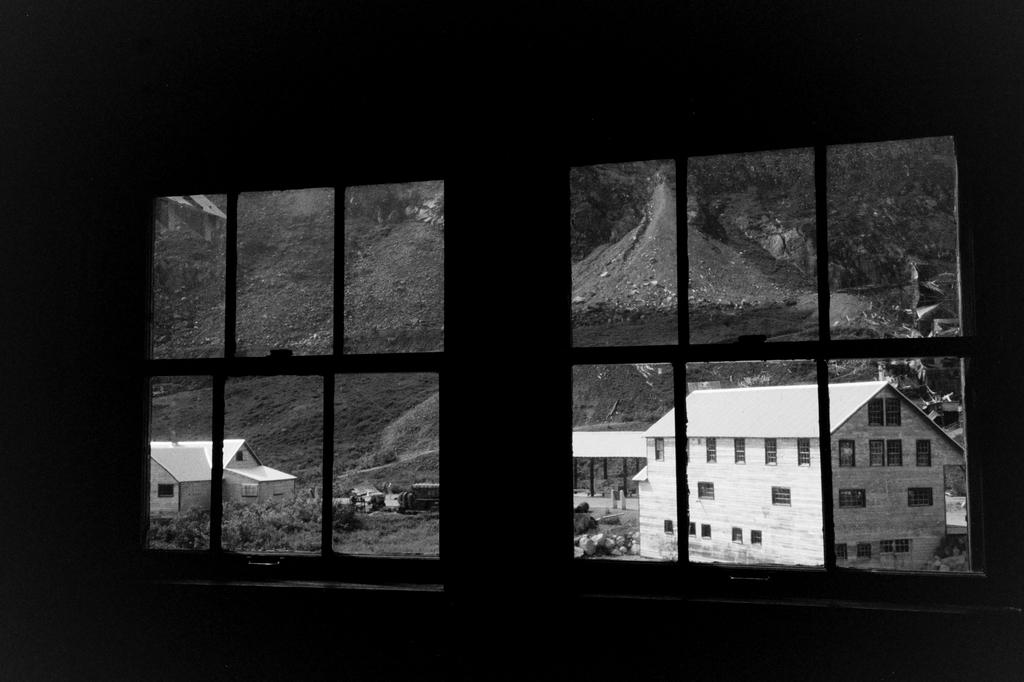What is the main feature of the window in the image? The window is made up of glass in the image. What is the window made of? The window is made of glass. What can be seen outside the window? Buildings, grass, and trees are visible outside the window. What is the opinion of the train on the window's design? There is no train present in the image, so it cannot have an opinion on the window's design. 